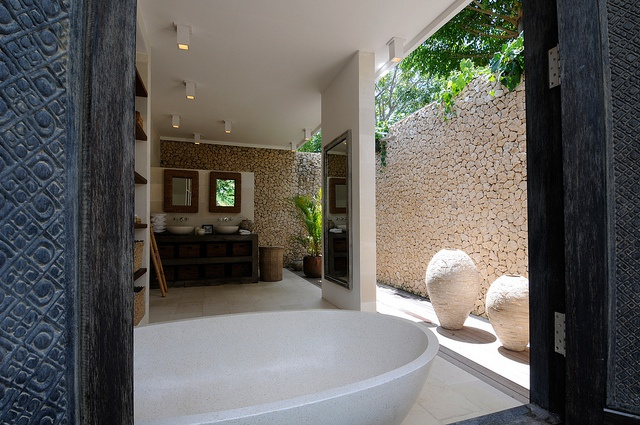Describe the objects in this image and their specific colors. I can see vase in black, darkgray, white, and tan tones, vase in black, tan, and white tones, potted plant in black, darkgreen, and gray tones, potted plant in black, green, ivory, and darkgray tones, and vase in black, maroon, and gray tones in this image. 